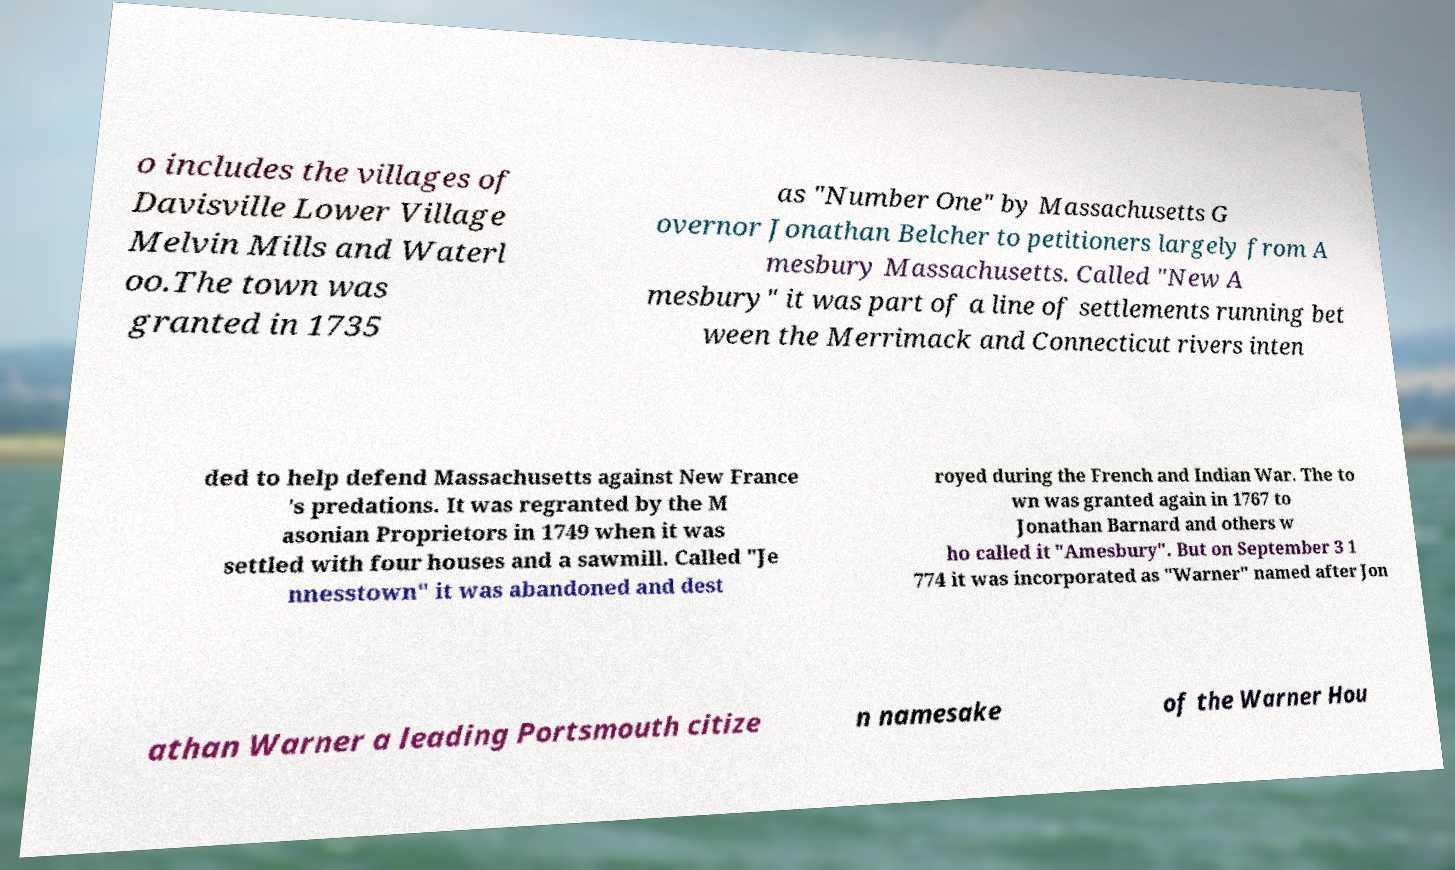I need the written content from this picture converted into text. Can you do that? o includes the villages of Davisville Lower Village Melvin Mills and Waterl oo.The town was granted in 1735 as "Number One" by Massachusetts G overnor Jonathan Belcher to petitioners largely from A mesbury Massachusetts. Called "New A mesbury" it was part of a line of settlements running bet ween the Merrimack and Connecticut rivers inten ded to help defend Massachusetts against New France 's predations. It was regranted by the M asonian Proprietors in 1749 when it was settled with four houses and a sawmill. Called "Je nnesstown" it was abandoned and dest royed during the French and Indian War. The to wn was granted again in 1767 to Jonathan Barnard and others w ho called it "Amesbury". But on September 3 1 774 it was incorporated as "Warner" named after Jon athan Warner a leading Portsmouth citize n namesake of the Warner Hou 